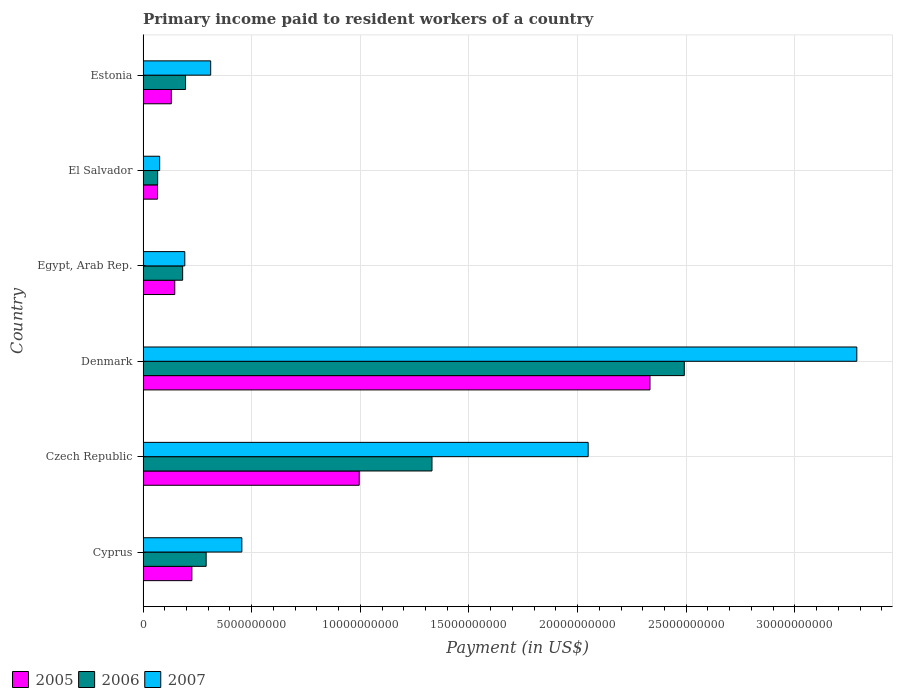How many groups of bars are there?
Offer a terse response. 6. Are the number of bars on each tick of the Y-axis equal?
Provide a short and direct response. Yes. How many bars are there on the 2nd tick from the bottom?
Offer a very short reply. 3. What is the label of the 2nd group of bars from the top?
Make the answer very short. El Salvador. What is the amount paid to workers in 2005 in Cyprus?
Keep it short and to the point. 2.25e+09. Across all countries, what is the maximum amount paid to workers in 2006?
Your response must be concise. 2.49e+1. Across all countries, what is the minimum amount paid to workers in 2006?
Give a very brief answer. 6.72e+08. In which country was the amount paid to workers in 2006 maximum?
Provide a short and direct response. Denmark. In which country was the amount paid to workers in 2005 minimum?
Ensure brevity in your answer.  El Salvador. What is the total amount paid to workers in 2007 in the graph?
Make the answer very short. 6.37e+1. What is the difference between the amount paid to workers in 2006 in Cyprus and that in Egypt, Arab Rep.?
Offer a terse response. 1.08e+09. What is the difference between the amount paid to workers in 2006 in Denmark and the amount paid to workers in 2007 in Cyprus?
Provide a short and direct response. 2.04e+1. What is the average amount paid to workers in 2005 per country?
Offer a very short reply. 6.49e+09. What is the difference between the amount paid to workers in 2006 and amount paid to workers in 2005 in Egypt, Arab Rep.?
Provide a succinct answer. 3.62e+08. In how many countries, is the amount paid to workers in 2007 greater than 18000000000 US$?
Ensure brevity in your answer.  2. What is the ratio of the amount paid to workers in 2005 in Denmark to that in Estonia?
Ensure brevity in your answer.  17.94. What is the difference between the highest and the second highest amount paid to workers in 2005?
Make the answer very short. 1.34e+1. What is the difference between the highest and the lowest amount paid to workers in 2007?
Your answer should be compact. 3.21e+1. In how many countries, is the amount paid to workers in 2007 greater than the average amount paid to workers in 2007 taken over all countries?
Make the answer very short. 2. Is the sum of the amount paid to workers in 2006 in Denmark and El Salvador greater than the maximum amount paid to workers in 2005 across all countries?
Your response must be concise. Yes. Are all the bars in the graph horizontal?
Your response must be concise. Yes. Are the values on the major ticks of X-axis written in scientific E-notation?
Give a very brief answer. No. Does the graph contain grids?
Give a very brief answer. Yes. How many legend labels are there?
Make the answer very short. 3. What is the title of the graph?
Your answer should be compact. Primary income paid to resident workers of a country. What is the label or title of the X-axis?
Give a very brief answer. Payment (in US$). What is the label or title of the Y-axis?
Provide a short and direct response. Country. What is the Payment (in US$) of 2005 in Cyprus?
Make the answer very short. 2.25e+09. What is the Payment (in US$) of 2006 in Cyprus?
Your response must be concise. 2.90e+09. What is the Payment (in US$) in 2007 in Cyprus?
Your answer should be very brief. 4.55e+09. What is the Payment (in US$) in 2005 in Czech Republic?
Ensure brevity in your answer.  9.95e+09. What is the Payment (in US$) of 2006 in Czech Republic?
Offer a terse response. 1.33e+1. What is the Payment (in US$) in 2007 in Czech Republic?
Offer a terse response. 2.05e+1. What is the Payment (in US$) of 2005 in Denmark?
Provide a succinct answer. 2.33e+1. What is the Payment (in US$) in 2006 in Denmark?
Your response must be concise. 2.49e+1. What is the Payment (in US$) in 2007 in Denmark?
Give a very brief answer. 3.29e+1. What is the Payment (in US$) of 2005 in Egypt, Arab Rep.?
Offer a very short reply. 1.46e+09. What is the Payment (in US$) of 2006 in Egypt, Arab Rep.?
Your response must be concise. 1.82e+09. What is the Payment (in US$) of 2007 in Egypt, Arab Rep.?
Provide a succinct answer. 1.92e+09. What is the Payment (in US$) in 2005 in El Salvador?
Your answer should be compact. 6.65e+08. What is the Payment (in US$) in 2006 in El Salvador?
Offer a terse response. 6.72e+08. What is the Payment (in US$) of 2007 in El Salvador?
Make the answer very short. 7.64e+08. What is the Payment (in US$) in 2005 in Estonia?
Your response must be concise. 1.30e+09. What is the Payment (in US$) in 2006 in Estonia?
Ensure brevity in your answer.  1.96e+09. What is the Payment (in US$) in 2007 in Estonia?
Offer a very short reply. 3.11e+09. Across all countries, what is the maximum Payment (in US$) of 2005?
Your response must be concise. 2.33e+1. Across all countries, what is the maximum Payment (in US$) of 2006?
Your answer should be compact. 2.49e+1. Across all countries, what is the maximum Payment (in US$) in 2007?
Provide a short and direct response. 3.29e+1. Across all countries, what is the minimum Payment (in US$) of 2005?
Give a very brief answer. 6.65e+08. Across all countries, what is the minimum Payment (in US$) of 2006?
Make the answer very short. 6.72e+08. Across all countries, what is the minimum Payment (in US$) in 2007?
Give a very brief answer. 7.64e+08. What is the total Payment (in US$) of 2005 in the graph?
Ensure brevity in your answer.  3.90e+1. What is the total Payment (in US$) of 2006 in the graph?
Your response must be concise. 4.56e+1. What is the total Payment (in US$) of 2007 in the graph?
Offer a very short reply. 6.37e+1. What is the difference between the Payment (in US$) in 2005 in Cyprus and that in Czech Republic?
Keep it short and to the point. -7.70e+09. What is the difference between the Payment (in US$) in 2006 in Cyprus and that in Czech Republic?
Provide a succinct answer. -1.04e+1. What is the difference between the Payment (in US$) of 2007 in Cyprus and that in Czech Republic?
Keep it short and to the point. -1.59e+1. What is the difference between the Payment (in US$) of 2005 in Cyprus and that in Denmark?
Make the answer very short. -2.11e+1. What is the difference between the Payment (in US$) in 2006 in Cyprus and that in Denmark?
Your answer should be very brief. -2.20e+1. What is the difference between the Payment (in US$) in 2007 in Cyprus and that in Denmark?
Ensure brevity in your answer.  -2.83e+1. What is the difference between the Payment (in US$) in 2005 in Cyprus and that in Egypt, Arab Rep.?
Your answer should be compact. 7.86e+08. What is the difference between the Payment (in US$) in 2006 in Cyprus and that in Egypt, Arab Rep.?
Offer a very short reply. 1.08e+09. What is the difference between the Payment (in US$) of 2007 in Cyprus and that in Egypt, Arab Rep.?
Provide a short and direct response. 2.63e+09. What is the difference between the Payment (in US$) of 2005 in Cyprus and that in El Salvador?
Give a very brief answer. 1.58e+09. What is the difference between the Payment (in US$) in 2006 in Cyprus and that in El Salvador?
Give a very brief answer. 2.23e+09. What is the difference between the Payment (in US$) of 2007 in Cyprus and that in El Salvador?
Provide a short and direct response. 3.78e+09. What is the difference between the Payment (in US$) of 2005 in Cyprus and that in Estonia?
Your answer should be compact. 9.46e+08. What is the difference between the Payment (in US$) in 2006 in Cyprus and that in Estonia?
Make the answer very short. 9.47e+08. What is the difference between the Payment (in US$) in 2007 in Cyprus and that in Estonia?
Offer a very short reply. 1.43e+09. What is the difference between the Payment (in US$) of 2005 in Czech Republic and that in Denmark?
Offer a terse response. -1.34e+1. What is the difference between the Payment (in US$) of 2006 in Czech Republic and that in Denmark?
Provide a short and direct response. -1.16e+1. What is the difference between the Payment (in US$) of 2007 in Czech Republic and that in Denmark?
Ensure brevity in your answer.  -1.24e+1. What is the difference between the Payment (in US$) of 2005 in Czech Republic and that in Egypt, Arab Rep.?
Ensure brevity in your answer.  8.49e+09. What is the difference between the Payment (in US$) in 2006 in Czech Republic and that in Egypt, Arab Rep.?
Your answer should be very brief. 1.15e+1. What is the difference between the Payment (in US$) of 2007 in Czech Republic and that in Egypt, Arab Rep.?
Offer a terse response. 1.86e+1. What is the difference between the Payment (in US$) in 2005 in Czech Republic and that in El Salvador?
Make the answer very short. 9.28e+09. What is the difference between the Payment (in US$) of 2006 in Czech Republic and that in El Salvador?
Ensure brevity in your answer.  1.26e+1. What is the difference between the Payment (in US$) of 2007 in Czech Republic and that in El Salvador?
Offer a terse response. 1.97e+1. What is the difference between the Payment (in US$) of 2005 in Czech Republic and that in Estonia?
Keep it short and to the point. 8.65e+09. What is the difference between the Payment (in US$) of 2006 in Czech Republic and that in Estonia?
Offer a terse response. 1.13e+1. What is the difference between the Payment (in US$) in 2007 in Czech Republic and that in Estonia?
Your answer should be compact. 1.74e+1. What is the difference between the Payment (in US$) of 2005 in Denmark and that in Egypt, Arab Rep.?
Your answer should be very brief. 2.19e+1. What is the difference between the Payment (in US$) in 2006 in Denmark and that in Egypt, Arab Rep.?
Your answer should be very brief. 2.31e+1. What is the difference between the Payment (in US$) of 2007 in Denmark and that in Egypt, Arab Rep.?
Your response must be concise. 3.09e+1. What is the difference between the Payment (in US$) of 2005 in Denmark and that in El Salvador?
Give a very brief answer. 2.27e+1. What is the difference between the Payment (in US$) in 2006 in Denmark and that in El Salvador?
Offer a very short reply. 2.42e+1. What is the difference between the Payment (in US$) of 2007 in Denmark and that in El Salvador?
Offer a terse response. 3.21e+1. What is the difference between the Payment (in US$) in 2005 in Denmark and that in Estonia?
Provide a short and direct response. 2.20e+1. What is the difference between the Payment (in US$) of 2006 in Denmark and that in Estonia?
Provide a short and direct response. 2.30e+1. What is the difference between the Payment (in US$) of 2007 in Denmark and that in Estonia?
Provide a succinct answer. 2.97e+1. What is the difference between the Payment (in US$) in 2005 in Egypt, Arab Rep. and that in El Salvador?
Keep it short and to the point. 7.95e+08. What is the difference between the Payment (in US$) in 2006 in Egypt, Arab Rep. and that in El Salvador?
Your response must be concise. 1.15e+09. What is the difference between the Payment (in US$) in 2007 in Egypt, Arab Rep. and that in El Salvador?
Your answer should be compact. 1.16e+09. What is the difference between the Payment (in US$) in 2005 in Egypt, Arab Rep. and that in Estonia?
Your answer should be compact. 1.60e+08. What is the difference between the Payment (in US$) in 2006 in Egypt, Arab Rep. and that in Estonia?
Provide a short and direct response. -1.34e+08. What is the difference between the Payment (in US$) in 2007 in Egypt, Arab Rep. and that in Estonia?
Ensure brevity in your answer.  -1.19e+09. What is the difference between the Payment (in US$) in 2005 in El Salvador and that in Estonia?
Keep it short and to the point. -6.35e+08. What is the difference between the Payment (in US$) in 2006 in El Salvador and that in Estonia?
Keep it short and to the point. -1.28e+09. What is the difference between the Payment (in US$) of 2007 in El Salvador and that in Estonia?
Ensure brevity in your answer.  -2.35e+09. What is the difference between the Payment (in US$) of 2005 in Cyprus and the Payment (in US$) of 2006 in Czech Republic?
Provide a succinct answer. -1.11e+1. What is the difference between the Payment (in US$) in 2005 in Cyprus and the Payment (in US$) in 2007 in Czech Republic?
Keep it short and to the point. -1.82e+1. What is the difference between the Payment (in US$) of 2006 in Cyprus and the Payment (in US$) of 2007 in Czech Republic?
Your answer should be very brief. -1.76e+1. What is the difference between the Payment (in US$) of 2005 in Cyprus and the Payment (in US$) of 2006 in Denmark?
Ensure brevity in your answer.  -2.27e+1. What is the difference between the Payment (in US$) in 2005 in Cyprus and the Payment (in US$) in 2007 in Denmark?
Keep it short and to the point. -3.06e+1. What is the difference between the Payment (in US$) in 2006 in Cyprus and the Payment (in US$) in 2007 in Denmark?
Give a very brief answer. -2.99e+1. What is the difference between the Payment (in US$) in 2005 in Cyprus and the Payment (in US$) in 2006 in Egypt, Arab Rep.?
Give a very brief answer. 4.24e+08. What is the difference between the Payment (in US$) of 2005 in Cyprus and the Payment (in US$) of 2007 in Egypt, Arab Rep.?
Provide a succinct answer. 3.26e+08. What is the difference between the Payment (in US$) in 2006 in Cyprus and the Payment (in US$) in 2007 in Egypt, Arab Rep.?
Keep it short and to the point. 9.83e+08. What is the difference between the Payment (in US$) of 2005 in Cyprus and the Payment (in US$) of 2006 in El Salvador?
Your response must be concise. 1.57e+09. What is the difference between the Payment (in US$) in 2005 in Cyprus and the Payment (in US$) in 2007 in El Salvador?
Offer a very short reply. 1.48e+09. What is the difference between the Payment (in US$) of 2006 in Cyprus and the Payment (in US$) of 2007 in El Salvador?
Offer a very short reply. 2.14e+09. What is the difference between the Payment (in US$) of 2005 in Cyprus and the Payment (in US$) of 2006 in Estonia?
Provide a succinct answer. 2.90e+08. What is the difference between the Payment (in US$) in 2005 in Cyprus and the Payment (in US$) in 2007 in Estonia?
Make the answer very short. -8.66e+08. What is the difference between the Payment (in US$) of 2006 in Cyprus and the Payment (in US$) of 2007 in Estonia?
Offer a very short reply. -2.09e+08. What is the difference between the Payment (in US$) of 2005 in Czech Republic and the Payment (in US$) of 2006 in Denmark?
Offer a very short reply. -1.50e+1. What is the difference between the Payment (in US$) of 2005 in Czech Republic and the Payment (in US$) of 2007 in Denmark?
Offer a very short reply. -2.29e+1. What is the difference between the Payment (in US$) of 2006 in Czech Republic and the Payment (in US$) of 2007 in Denmark?
Make the answer very short. -1.96e+1. What is the difference between the Payment (in US$) of 2005 in Czech Republic and the Payment (in US$) of 2006 in Egypt, Arab Rep.?
Give a very brief answer. 8.13e+09. What is the difference between the Payment (in US$) in 2005 in Czech Republic and the Payment (in US$) in 2007 in Egypt, Arab Rep.?
Keep it short and to the point. 8.03e+09. What is the difference between the Payment (in US$) of 2006 in Czech Republic and the Payment (in US$) of 2007 in Egypt, Arab Rep.?
Make the answer very short. 1.14e+1. What is the difference between the Payment (in US$) of 2005 in Czech Republic and the Payment (in US$) of 2006 in El Salvador?
Your response must be concise. 9.28e+09. What is the difference between the Payment (in US$) in 2005 in Czech Republic and the Payment (in US$) in 2007 in El Salvador?
Provide a short and direct response. 9.18e+09. What is the difference between the Payment (in US$) in 2006 in Czech Republic and the Payment (in US$) in 2007 in El Salvador?
Offer a terse response. 1.25e+1. What is the difference between the Payment (in US$) in 2005 in Czech Republic and the Payment (in US$) in 2006 in Estonia?
Your answer should be very brief. 7.99e+09. What is the difference between the Payment (in US$) of 2005 in Czech Republic and the Payment (in US$) of 2007 in Estonia?
Offer a terse response. 6.84e+09. What is the difference between the Payment (in US$) in 2006 in Czech Republic and the Payment (in US$) in 2007 in Estonia?
Make the answer very short. 1.02e+1. What is the difference between the Payment (in US$) of 2005 in Denmark and the Payment (in US$) of 2006 in Egypt, Arab Rep.?
Your answer should be very brief. 2.15e+1. What is the difference between the Payment (in US$) in 2005 in Denmark and the Payment (in US$) in 2007 in Egypt, Arab Rep.?
Offer a very short reply. 2.14e+1. What is the difference between the Payment (in US$) of 2006 in Denmark and the Payment (in US$) of 2007 in Egypt, Arab Rep.?
Your response must be concise. 2.30e+1. What is the difference between the Payment (in US$) in 2005 in Denmark and the Payment (in US$) in 2006 in El Salvador?
Your answer should be very brief. 2.27e+1. What is the difference between the Payment (in US$) of 2005 in Denmark and the Payment (in US$) of 2007 in El Salvador?
Your answer should be very brief. 2.26e+1. What is the difference between the Payment (in US$) in 2006 in Denmark and the Payment (in US$) in 2007 in El Salvador?
Provide a succinct answer. 2.41e+1. What is the difference between the Payment (in US$) in 2005 in Denmark and the Payment (in US$) in 2006 in Estonia?
Provide a short and direct response. 2.14e+1. What is the difference between the Payment (in US$) of 2005 in Denmark and the Payment (in US$) of 2007 in Estonia?
Make the answer very short. 2.02e+1. What is the difference between the Payment (in US$) in 2006 in Denmark and the Payment (in US$) in 2007 in Estonia?
Keep it short and to the point. 2.18e+1. What is the difference between the Payment (in US$) of 2005 in Egypt, Arab Rep. and the Payment (in US$) of 2006 in El Salvador?
Provide a short and direct response. 7.88e+08. What is the difference between the Payment (in US$) of 2005 in Egypt, Arab Rep. and the Payment (in US$) of 2007 in El Salvador?
Provide a succinct answer. 6.96e+08. What is the difference between the Payment (in US$) in 2006 in Egypt, Arab Rep. and the Payment (in US$) in 2007 in El Salvador?
Keep it short and to the point. 1.06e+09. What is the difference between the Payment (in US$) of 2005 in Egypt, Arab Rep. and the Payment (in US$) of 2006 in Estonia?
Offer a very short reply. -4.96e+08. What is the difference between the Payment (in US$) of 2005 in Egypt, Arab Rep. and the Payment (in US$) of 2007 in Estonia?
Your response must be concise. -1.65e+09. What is the difference between the Payment (in US$) in 2006 in Egypt, Arab Rep. and the Payment (in US$) in 2007 in Estonia?
Your response must be concise. -1.29e+09. What is the difference between the Payment (in US$) of 2005 in El Salvador and the Payment (in US$) of 2006 in Estonia?
Keep it short and to the point. -1.29e+09. What is the difference between the Payment (in US$) in 2005 in El Salvador and the Payment (in US$) in 2007 in Estonia?
Keep it short and to the point. -2.45e+09. What is the difference between the Payment (in US$) of 2006 in El Salvador and the Payment (in US$) of 2007 in Estonia?
Provide a short and direct response. -2.44e+09. What is the average Payment (in US$) of 2005 per country?
Your response must be concise. 6.49e+09. What is the average Payment (in US$) of 2006 per country?
Your response must be concise. 7.59e+09. What is the average Payment (in US$) in 2007 per country?
Your answer should be very brief. 1.06e+1. What is the difference between the Payment (in US$) of 2005 and Payment (in US$) of 2006 in Cyprus?
Your response must be concise. -6.57e+08. What is the difference between the Payment (in US$) of 2005 and Payment (in US$) of 2007 in Cyprus?
Offer a very short reply. -2.30e+09. What is the difference between the Payment (in US$) of 2006 and Payment (in US$) of 2007 in Cyprus?
Keep it short and to the point. -1.64e+09. What is the difference between the Payment (in US$) in 2005 and Payment (in US$) in 2006 in Czech Republic?
Offer a terse response. -3.35e+09. What is the difference between the Payment (in US$) in 2005 and Payment (in US$) in 2007 in Czech Republic?
Keep it short and to the point. -1.05e+1. What is the difference between the Payment (in US$) of 2006 and Payment (in US$) of 2007 in Czech Republic?
Offer a terse response. -7.19e+09. What is the difference between the Payment (in US$) of 2005 and Payment (in US$) of 2006 in Denmark?
Your answer should be very brief. -1.58e+09. What is the difference between the Payment (in US$) of 2005 and Payment (in US$) of 2007 in Denmark?
Keep it short and to the point. -9.52e+09. What is the difference between the Payment (in US$) in 2006 and Payment (in US$) in 2007 in Denmark?
Your response must be concise. -7.94e+09. What is the difference between the Payment (in US$) in 2005 and Payment (in US$) in 2006 in Egypt, Arab Rep.?
Your answer should be compact. -3.62e+08. What is the difference between the Payment (in US$) in 2005 and Payment (in US$) in 2007 in Egypt, Arab Rep.?
Keep it short and to the point. -4.61e+08. What is the difference between the Payment (in US$) of 2006 and Payment (in US$) of 2007 in Egypt, Arab Rep.?
Provide a succinct answer. -9.87e+07. What is the difference between the Payment (in US$) in 2005 and Payment (in US$) in 2006 in El Salvador?
Keep it short and to the point. -6.92e+06. What is the difference between the Payment (in US$) of 2005 and Payment (in US$) of 2007 in El Salvador?
Provide a short and direct response. -9.93e+07. What is the difference between the Payment (in US$) of 2006 and Payment (in US$) of 2007 in El Salvador?
Your answer should be compact. -9.24e+07. What is the difference between the Payment (in US$) in 2005 and Payment (in US$) in 2006 in Estonia?
Offer a terse response. -6.56e+08. What is the difference between the Payment (in US$) of 2005 and Payment (in US$) of 2007 in Estonia?
Offer a very short reply. -1.81e+09. What is the difference between the Payment (in US$) of 2006 and Payment (in US$) of 2007 in Estonia?
Make the answer very short. -1.16e+09. What is the ratio of the Payment (in US$) of 2005 in Cyprus to that in Czech Republic?
Your answer should be very brief. 0.23. What is the ratio of the Payment (in US$) in 2006 in Cyprus to that in Czech Republic?
Your response must be concise. 0.22. What is the ratio of the Payment (in US$) in 2007 in Cyprus to that in Czech Republic?
Give a very brief answer. 0.22. What is the ratio of the Payment (in US$) in 2005 in Cyprus to that in Denmark?
Give a very brief answer. 0.1. What is the ratio of the Payment (in US$) of 2006 in Cyprus to that in Denmark?
Offer a very short reply. 0.12. What is the ratio of the Payment (in US$) in 2007 in Cyprus to that in Denmark?
Give a very brief answer. 0.14. What is the ratio of the Payment (in US$) of 2005 in Cyprus to that in Egypt, Arab Rep.?
Provide a succinct answer. 1.54. What is the ratio of the Payment (in US$) in 2006 in Cyprus to that in Egypt, Arab Rep.?
Provide a short and direct response. 1.59. What is the ratio of the Payment (in US$) of 2007 in Cyprus to that in Egypt, Arab Rep.?
Your response must be concise. 2.37. What is the ratio of the Payment (in US$) in 2005 in Cyprus to that in El Salvador?
Provide a short and direct response. 3.38. What is the ratio of the Payment (in US$) in 2006 in Cyprus to that in El Salvador?
Offer a very short reply. 4.32. What is the ratio of the Payment (in US$) in 2007 in Cyprus to that in El Salvador?
Ensure brevity in your answer.  5.95. What is the ratio of the Payment (in US$) in 2005 in Cyprus to that in Estonia?
Your response must be concise. 1.73. What is the ratio of the Payment (in US$) of 2006 in Cyprus to that in Estonia?
Offer a very short reply. 1.48. What is the ratio of the Payment (in US$) of 2007 in Cyprus to that in Estonia?
Provide a succinct answer. 1.46. What is the ratio of the Payment (in US$) of 2005 in Czech Republic to that in Denmark?
Provide a succinct answer. 0.43. What is the ratio of the Payment (in US$) in 2006 in Czech Republic to that in Denmark?
Your response must be concise. 0.53. What is the ratio of the Payment (in US$) in 2007 in Czech Republic to that in Denmark?
Make the answer very short. 0.62. What is the ratio of the Payment (in US$) in 2005 in Czech Republic to that in Egypt, Arab Rep.?
Offer a terse response. 6.81. What is the ratio of the Payment (in US$) of 2006 in Czech Republic to that in Egypt, Arab Rep.?
Provide a succinct answer. 7.3. What is the ratio of the Payment (in US$) of 2007 in Czech Republic to that in Egypt, Arab Rep.?
Your response must be concise. 10.67. What is the ratio of the Payment (in US$) in 2005 in Czech Republic to that in El Salvador?
Your answer should be compact. 14.96. What is the ratio of the Payment (in US$) of 2006 in Czech Republic to that in El Salvador?
Make the answer very short. 19.79. What is the ratio of the Payment (in US$) of 2007 in Czech Republic to that in El Salvador?
Offer a very short reply. 26.8. What is the ratio of the Payment (in US$) in 2005 in Czech Republic to that in Estonia?
Offer a terse response. 7.65. What is the ratio of the Payment (in US$) in 2006 in Czech Republic to that in Estonia?
Offer a terse response. 6.8. What is the ratio of the Payment (in US$) of 2007 in Czech Republic to that in Estonia?
Provide a short and direct response. 6.58. What is the ratio of the Payment (in US$) in 2005 in Denmark to that in Egypt, Arab Rep.?
Provide a short and direct response. 15.98. What is the ratio of the Payment (in US$) in 2006 in Denmark to that in Egypt, Arab Rep.?
Provide a short and direct response. 13.67. What is the ratio of the Payment (in US$) of 2007 in Denmark to that in Egypt, Arab Rep.?
Keep it short and to the point. 17.1. What is the ratio of the Payment (in US$) in 2005 in Denmark to that in El Salvador?
Your response must be concise. 35.08. What is the ratio of the Payment (in US$) in 2006 in Denmark to that in El Salvador?
Your response must be concise. 37.07. What is the ratio of the Payment (in US$) in 2007 in Denmark to that in El Salvador?
Provide a succinct answer. 42.98. What is the ratio of the Payment (in US$) of 2005 in Denmark to that in Estonia?
Provide a succinct answer. 17.94. What is the ratio of the Payment (in US$) in 2006 in Denmark to that in Estonia?
Your answer should be very brief. 12.73. What is the ratio of the Payment (in US$) in 2007 in Denmark to that in Estonia?
Offer a very short reply. 10.55. What is the ratio of the Payment (in US$) in 2005 in Egypt, Arab Rep. to that in El Salvador?
Provide a succinct answer. 2.2. What is the ratio of the Payment (in US$) of 2006 in Egypt, Arab Rep. to that in El Salvador?
Your answer should be compact. 2.71. What is the ratio of the Payment (in US$) in 2007 in Egypt, Arab Rep. to that in El Salvador?
Keep it short and to the point. 2.51. What is the ratio of the Payment (in US$) in 2005 in Egypt, Arab Rep. to that in Estonia?
Your answer should be compact. 1.12. What is the ratio of the Payment (in US$) in 2006 in Egypt, Arab Rep. to that in Estonia?
Offer a terse response. 0.93. What is the ratio of the Payment (in US$) of 2007 in Egypt, Arab Rep. to that in Estonia?
Your answer should be compact. 0.62. What is the ratio of the Payment (in US$) in 2005 in El Salvador to that in Estonia?
Ensure brevity in your answer.  0.51. What is the ratio of the Payment (in US$) in 2006 in El Salvador to that in Estonia?
Provide a succinct answer. 0.34. What is the ratio of the Payment (in US$) of 2007 in El Salvador to that in Estonia?
Ensure brevity in your answer.  0.25. What is the difference between the highest and the second highest Payment (in US$) of 2005?
Your answer should be compact. 1.34e+1. What is the difference between the highest and the second highest Payment (in US$) of 2006?
Offer a very short reply. 1.16e+1. What is the difference between the highest and the second highest Payment (in US$) of 2007?
Ensure brevity in your answer.  1.24e+1. What is the difference between the highest and the lowest Payment (in US$) in 2005?
Offer a terse response. 2.27e+1. What is the difference between the highest and the lowest Payment (in US$) in 2006?
Your response must be concise. 2.42e+1. What is the difference between the highest and the lowest Payment (in US$) in 2007?
Offer a terse response. 3.21e+1. 